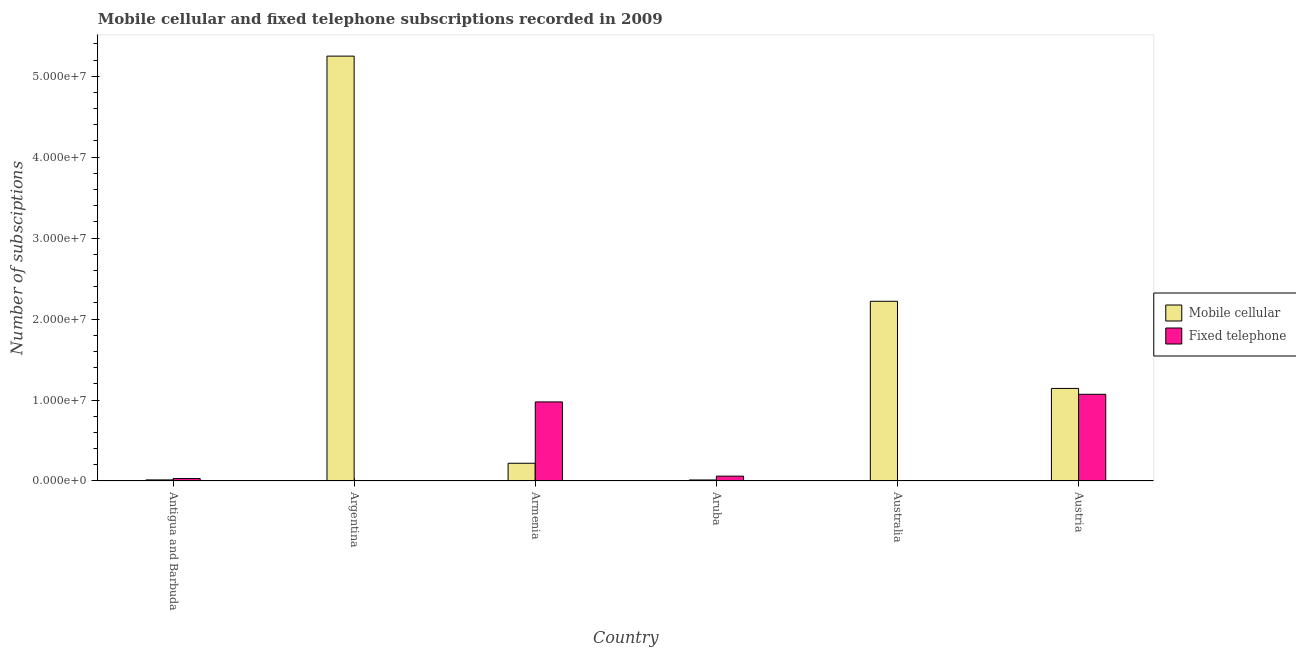How many groups of bars are there?
Ensure brevity in your answer.  6. Are the number of bars on each tick of the X-axis equal?
Provide a short and direct response. Yes. How many bars are there on the 2nd tick from the right?
Your response must be concise. 2. What is the label of the 3rd group of bars from the left?
Give a very brief answer. Armenia. What is the number of fixed telephone subscriptions in Antigua and Barbuda?
Offer a very short reply. 3.03e+05. Across all countries, what is the maximum number of mobile cellular subscriptions?
Provide a short and direct response. 5.25e+07. Across all countries, what is the minimum number of fixed telephone subscriptions?
Provide a short and direct response. 3.67e+04. In which country was the number of mobile cellular subscriptions minimum?
Keep it short and to the point. Aruba. What is the total number of fixed telephone subscriptions in the graph?
Your answer should be very brief. 2.15e+07. What is the difference between the number of fixed telephone subscriptions in Antigua and Barbuda and that in Austria?
Make the answer very short. -1.04e+07. What is the difference between the number of fixed telephone subscriptions in Australia and the number of mobile cellular subscriptions in Aruba?
Offer a very short reply. -9.13e+04. What is the average number of fixed telephone subscriptions per country?
Give a very brief answer. 3.58e+06. What is the difference between the number of mobile cellular subscriptions and number of fixed telephone subscriptions in Aruba?
Offer a very short reply. -4.72e+05. What is the ratio of the number of fixed telephone subscriptions in Antigua and Barbuda to that in Aruba?
Provide a short and direct response. 0.51. Is the number of mobile cellular subscriptions in Armenia less than that in Austria?
Provide a short and direct response. Yes. Is the difference between the number of mobile cellular subscriptions in Armenia and Aruba greater than the difference between the number of fixed telephone subscriptions in Armenia and Aruba?
Your response must be concise. No. What is the difference between the highest and the second highest number of fixed telephone subscriptions?
Offer a very short reply. 9.41e+05. What is the difference between the highest and the lowest number of mobile cellular subscriptions?
Your response must be concise. 5.24e+07. In how many countries, is the number of mobile cellular subscriptions greater than the average number of mobile cellular subscriptions taken over all countries?
Make the answer very short. 2. What does the 2nd bar from the left in Argentina represents?
Offer a terse response. Fixed telephone. What does the 1st bar from the right in Antigua and Barbuda represents?
Ensure brevity in your answer.  Fixed telephone. How many bars are there?
Provide a short and direct response. 12. Does the graph contain any zero values?
Offer a very short reply. No. What is the title of the graph?
Your answer should be compact. Mobile cellular and fixed telephone subscriptions recorded in 2009. Does "Public funds" appear as one of the legend labels in the graph?
Make the answer very short. No. What is the label or title of the Y-axis?
Make the answer very short. Number of subsciptions. What is the Number of subsciptions of Mobile cellular in Antigua and Barbuda?
Provide a short and direct response. 1.35e+05. What is the Number of subsciptions of Fixed telephone in Antigua and Barbuda?
Provide a short and direct response. 3.03e+05. What is the Number of subsciptions of Mobile cellular in Argentina?
Your answer should be very brief. 5.25e+07. What is the Number of subsciptions in Fixed telephone in Argentina?
Offer a terse response. 3.74e+04. What is the Number of subsciptions in Mobile cellular in Armenia?
Give a very brief answer. 2.19e+06. What is the Number of subsciptions of Fixed telephone in Armenia?
Provide a short and direct response. 9.77e+06. What is the Number of subsciptions of Mobile cellular in Aruba?
Give a very brief answer. 1.28e+05. What is the Number of subsciptions of Fixed telephone in Aruba?
Offer a very short reply. 6.00e+05. What is the Number of subsciptions in Mobile cellular in Australia?
Ensure brevity in your answer.  2.22e+07. What is the Number of subsciptions in Fixed telephone in Australia?
Make the answer very short. 3.67e+04. What is the Number of subsciptions in Mobile cellular in Austria?
Provide a succinct answer. 1.14e+07. What is the Number of subsciptions of Fixed telephone in Austria?
Offer a very short reply. 1.07e+07. Across all countries, what is the maximum Number of subsciptions in Mobile cellular?
Your response must be concise. 5.25e+07. Across all countries, what is the maximum Number of subsciptions of Fixed telephone?
Keep it short and to the point. 1.07e+07. Across all countries, what is the minimum Number of subsciptions in Mobile cellular?
Offer a very short reply. 1.28e+05. Across all countries, what is the minimum Number of subsciptions in Fixed telephone?
Your answer should be compact. 3.67e+04. What is the total Number of subsciptions in Mobile cellular in the graph?
Give a very brief answer. 8.86e+07. What is the total Number of subsciptions of Fixed telephone in the graph?
Your answer should be compact. 2.15e+07. What is the difference between the Number of subsciptions in Mobile cellular in Antigua and Barbuda and that in Argentina?
Your answer should be compact. -5.23e+07. What is the difference between the Number of subsciptions in Fixed telephone in Antigua and Barbuda and that in Argentina?
Your response must be concise. 2.66e+05. What is the difference between the Number of subsciptions of Mobile cellular in Antigua and Barbuda and that in Armenia?
Give a very brief answer. -2.06e+06. What is the difference between the Number of subsciptions of Fixed telephone in Antigua and Barbuda and that in Armenia?
Your answer should be compact. -9.46e+06. What is the difference between the Number of subsciptions in Mobile cellular in Antigua and Barbuda and that in Aruba?
Provide a short and direct response. 6925. What is the difference between the Number of subsciptions in Fixed telephone in Antigua and Barbuda and that in Aruba?
Your answer should be compact. -2.97e+05. What is the difference between the Number of subsciptions of Mobile cellular in Antigua and Barbuda and that in Australia?
Offer a terse response. -2.21e+07. What is the difference between the Number of subsciptions in Fixed telephone in Antigua and Barbuda and that in Australia?
Make the answer very short. 2.66e+05. What is the difference between the Number of subsciptions in Mobile cellular in Antigua and Barbuda and that in Austria?
Ensure brevity in your answer.  -1.13e+07. What is the difference between the Number of subsciptions of Fixed telephone in Antigua and Barbuda and that in Austria?
Provide a short and direct response. -1.04e+07. What is the difference between the Number of subsciptions in Mobile cellular in Argentina and that in Armenia?
Keep it short and to the point. 5.03e+07. What is the difference between the Number of subsciptions of Fixed telephone in Argentina and that in Armenia?
Ensure brevity in your answer.  -9.73e+06. What is the difference between the Number of subsciptions in Mobile cellular in Argentina and that in Aruba?
Your answer should be very brief. 5.24e+07. What is the difference between the Number of subsciptions in Fixed telephone in Argentina and that in Aruba?
Your response must be concise. -5.63e+05. What is the difference between the Number of subsciptions of Mobile cellular in Argentina and that in Australia?
Provide a succinct answer. 3.03e+07. What is the difference between the Number of subsciptions of Fixed telephone in Argentina and that in Australia?
Keep it short and to the point. 650. What is the difference between the Number of subsciptions in Mobile cellular in Argentina and that in Austria?
Offer a very short reply. 4.10e+07. What is the difference between the Number of subsciptions of Fixed telephone in Argentina and that in Austria?
Your answer should be compact. -1.07e+07. What is the difference between the Number of subsciptions in Mobile cellular in Armenia and that in Aruba?
Provide a succinct answer. 2.06e+06. What is the difference between the Number of subsciptions in Fixed telephone in Armenia and that in Aruba?
Make the answer very short. 9.17e+06. What is the difference between the Number of subsciptions of Mobile cellular in Armenia and that in Australia?
Offer a terse response. -2.00e+07. What is the difference between the Number of subsciptions of Fixed telephone in Armenia and that in Australia?
Your answer should be very brief. 9.73e+06. What is the difference between the Number of subsciptions in Mobile cellular in Armenia and that in Austria?
Keep it short and to the point. -9.24e+06. What is the difference between the Number of subsciptions in Fixed telephone in Armenia and that in Austria?
Make the answer very short. -9.41e+05. What is the difference between the Number of subsciptions of Mobile cellular in Aruba and that in Australia?
Make the answer very short. -2.21e+07. What is the difference between the Number of subsciptions of Fixed telephone in Aruba and that in Australia?
Ensure brevity in your answer.  5.63e+05. What is the difference between the Number of subsciptions of Mobile cellular in Aruba and that in Austria?
Your response must be concise. -1.13e+07. What is the difference between the Number of subsciptions in Fixed telephone in Aruba and that in Austria?
Your answer should be compact. -1.01e+07. What is the difference between the Number of subsciptions in Mobile cellular in Australia and that in Austria?
Provide a succinct answer. 1.08e+07. What is the difference between the Number of subsciptions in Fixed telephone in Australia and that in Austria?
Make the answer very short. -1.07e+07. What is the difference between the Number of subsciptions of Mobile cellular in Antigua and Barbuda and the Number of subsciptions of Fixed telephone in Argentina?
Your response must be concise. 9.76e+04. What is the difference between the Number of subsciptions in Mobile cellular in Antigua and Barbuda and the Number of subsciptions in Fixed telephone in Armenia?
Offer a terse response. -9.63e+06. What is the difference between the Number of subsciptions of Mobile cellular in Antigua and Barbuda and the Number of subsciptions of Fixed telephone in Aruba?
Make the answer very short. -4.65e+05. What is the difference between the Number of subsciptions in Mobile cellular in Antigua and Barbuda and the Number of subsciptions in Fixed telephone in Australia?
Your answer should be very brief. 9.82e+04. What is the difference between the Number of subsciptions in Mobile cellular in Antigua and Barbuda and the Number of subsciptions in Fixed telephone in Austria?
Your response must be concise. -1.06e+07. What is the difference between the Number of subsciptions in Mobile cellular in Argentina and the Number of subsciptions in Fixed telephone in Armenia?
Your answer should be very brief. 4.27e+07. What is the difference between the Number of subsciptions of Mobile cellular in Argentina and the Number of subsciptions of Fixed telephone in Aruba?
Your answer should be compact. 5.19e+07. What is the difference between the Number of subsciptions of Mobile cellular in Argentina and the Number of subsciptions of Fixed telephone in Australia?
Your answer should be very brief. 5.24e+07. What is the difference between the Number of subsciptions of Mobile cellular in Argentina and the Number of subsciptions of Fixed telephone in Austria?
Give a very brief answer. 4.18e+07. What is the difference between the Number of subsciptions in Mobile cellular in Armenia and the Number of subsciptions in Fixed telephone in Aruba?
Provide a short and direct response. 1.59e+06. What is the difference between the Number of subsciptions of Mobile cellular in Armenia and the Number of subsciptions of Fixed telephone in Australia?
Give a very brief answer. 2.15e+06. What is the difference between the Number of subsciptions in Mobile cellular in Armenia and the Number of subsciptions in Fixed telephone in Austria?
Make the answer very short. -8.52e+06. What is the difference between the Number of subsciptions in Mobile cellular in Aruba and the Number of subsciptions in Fixed telephone in Australia?
Your response must be concise. 9.13e+04. What is the difference between the Number of subsciptions of Mobile cellular in Aruba and the Number of subsciptions of Fixed telephone in Austria?
Provide a short and direct response. -1.06e+07. What is the difference between the Number of subsciptions in Mobile cellular in Australia and the Number of subsciptions in Fixed telephone in Austria?
Your answer should be very brief. 1.15e+07. What is the average Number of subsciptions in Mobile cellular per country?
Ensure brevity in your answer.  1.48e+07. What is the average Number of subsciptions in Fixed telephone per country?
Your response must be concise. 3.58e+06. What is the difference between the Number of subsciptions of Mobile cellular and Number of subsciptions of Fixed telephone in Antigua and Barbuda?
Offer a very short reply. -1.68e+05. What is the difference between the Number of subsciptions in Mobile cellular and Number of subsciptions in Fixed telephone in Argentina?
Offer a terse response. 5.24e+07. What is the difference between the Number of subsciptions in Mobile cellular and Number of subsciptions in Fixed telephone in Armenia?
Keep it short and to the point. -7.58e+06. What is the difference between the Number of subsciptions of Mobile cellular and Number of subsciptions of Fixed telephone in Aruba?
Make the answer very short. -4.72e+05. What is the difference between the Number of subsciptions in Mobile cellular and Number of subsciptions in Fixed telephone in Australia?
Offer a very short reply. 2.22e+07. What is the difference between the Number of subsciptions of Mobile cellular and Number of subsciptions of Fixed telephone in Austria?
Offer a very short reply. 7.25e+05. What is the ratio of the Number of subsciptions in Mobile cellular in Antigua and Barbuda to that in Argentina?
Provide a short and direct response. 0. What is the ratio of the Number of subsciptions of Fixed telephone in Antigua and Barbuda to that in Argentina?
Your answer should be compact. 8.12. What is the ratio of the Number of subsciptions of Mobile cellular in Antigua and Barbuda to that in Armenia?
Provide a short and direct response. 0.06. What is the ratio of the Number of subsciptions of Fixed telephone in Antigua and Barbuda to that in Armenia?
Offer a terse response. 0.03. What is the ratio of the Number of subsciptions of Mobile cellular in Antigua and Barbuda to that in Aruba?
Provide a succinct answer. 1.05. What is the ratio of the Number of subsciptions in Fixed telephone in Antigua and Barbuda to that in Aruba?
Make the answer very short. 0.51. What is the ratio of the Number of subsciptions in Mobile cellular in Antigua and Barbuda to that in Australia?
Provide a short and direct response. 0.01. What is the ratio of the Number of subsciptions in Fixed telephone in Antigua and Barbuda to that in Australia?
Your answer should be very brief. 8.26. What is the ratio of the Number of subsciptions in Mobile cellular in Antigua and Barbuda to that in Austria?
Give a very brief answer. 0.01. What is the ratio of the Number of subsciptions of Fixed telephone in Antigua and Barbuda to that in Austria?
Your response must be concise. 0.03. What is the ratio of the Number of subsciptions in Mobile cellular in Argentina to that in Armenia?
Ensure brevity in your answer.  23.95. What is the ratio of the Number of subsciptions of Fixed telephone in Argentina to that in Armenia?
Your response must be concise. 0. What is the ratio of the Number of subsciptions in Mobile cellular in Argentina to that in Aruba?
Make the answer very short. 410.02. What is the ratio of the Number of subsciptions of Fixed telephone in Argentina to that in Aruba?
Provide a short and direct response. 0.06. What is the ratio of the Number of subsciptions in Mobile cellular in Argentina to that in Australia?
Keep it short and to the point. 2.36. What is the ratio of the Number of subsciptions in Fixed telephone in Argentina to that in Australia?
Provide a succinct answer. 1.02. What is the ratio of the Number of subsciptions of Mobile cellular in Argentina to that in Austria?
Your answer should be very brief. 4.59. What is the ratio of the Number of subsciptions of Fixed telephone in Argentina to that in Austria?
Offer a terse response. 0. What is the ratio of the Number of subsciptions of Mobile cellular in Armenia to that in Aruba?
Provide a succinct answer. 17.12. What is the ratio of the Number of subsciptions in Fixed telephone in Armenia to that in Aruba?
Provide a short and direct response. 16.28. What is the ratio of the Number of subsciptions in Mobile cellular in Armenia to that in Australia?
Provide a short and direct response. 0.1. What is the ratio of the Number of subsciptions in Fixed telephone in Armenia to that in Australia?
Provide a succinct answer. 266.16. What is the ratio of the Number of subsciptions in Mobile cellular in Armenia to that in Austria?
Provide a succinct answer. 0.19. What is the ratio of the Number of subsciptions of Fixed telephone in Armenia to that in Austria?
Make the answer very short. 0.91. What is the ratio of the Number of subsciptions in Mobile cellular in Aruba to that in Australia?
Provide a succinct answer. 0.01. What is the ratio of the Number of subsciptions in Fixed telephone in Aruba to that in Australia?
Provide a succinct answer. 16.35. What is the ratio of the Number of subsciptions in Mobile cellular in Aruba to that in Austria?
Your response must be concise. 0.01. What is the ratio of the Number of subsciptions in Fixed telephone in Aruba to that in Austria?
Give a very brief answer. 0.06. What is the ratio of the Number of subsciptions in Mobile cellular in Australia to that in Austria?
Offer a very short reply. 1.94. What is the ratio of the Number of subsciptions in Fixed telephone in Australia to that in Austria?
Provide a short and direct response. 0. What is the difference between the highest and the second highest Number of subsciptions in Mobile cellular?
Offer a very short reply. 3.03e+07. What is the difference between the highest and the second highest Number of subsciptions in Fixed telephone?
Give a very brief answer. 9.41e+05. What is the difference between the highest and the lowest Number of subsciptions in Mobile cellular?
Keep it short and to the point. 5.24e+07. What is the difference between the highest and the lowest Number of subsciptions of Fixed telephone?
Your response must be concise. 1.07e+07. 